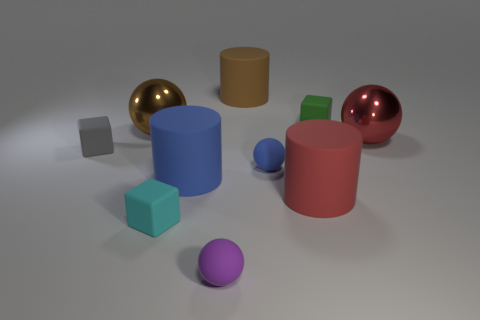Subtract all balls. How many objects are left? 6 Subtract all big brown metal objects. Subtract all cubes. How many objects are left? 6 Add 4 tiny rubber spheres. How many tiny rubber spheres are left? 6 Add 1 red things. How many red things exist? 3 Subtract 1 blue spheres. How many objects are left? 9 